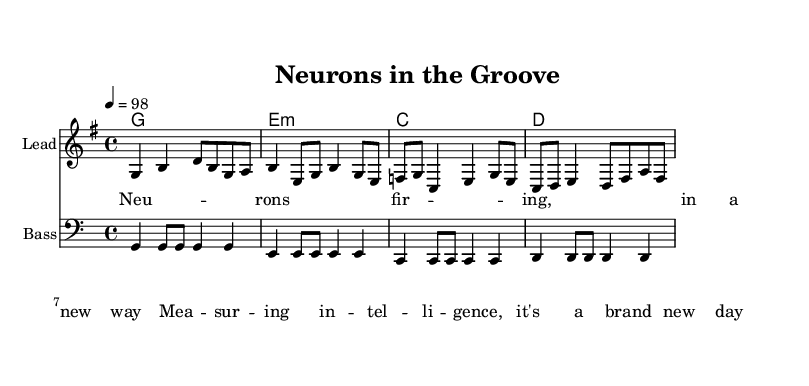What is the key signature of this music? The key signature indicated in the piece is G major, which has one sharp (F#). This can be determined from the global section of the code that sets the key signature to G major.
Answer: G major What is the time signature of this music? The time signature in the music is 4/4, meaning there are four beats in a measure and the quarter note gets one beat. This is also stated in the global section of the code.
Answer: 4/4 What is the tempo marking of this tune? The tempo marking is 98 beats per minute, which is specified in the global section of the code. This indicates the speed at which the piece should be played.
Answer: 98 How many measures are in the melody? The melody contains four measures, as counted from the melody section in the code. Each measure is separated by a bar line, and there are a total of four distinct groups of notes.
Answer: 4 What is the main theme of the lyrics? The main theme of the lyrics discusses new ways of measuring intelligence through the firing of neurons, which connects to scientific discoveries. This can be inferred from the content presented in the verse.
Answer: Intelligence and neurons What type of musical elements are used in reggae as seen in this piece? The reggae style in this piece is indicated by the offbeat guitar chords (common in reggae rhythm), consistent bass lines, and the emphasis on the second and fourth beats, reflecting the genre’s characteristics. This can be inferred from the structure of the harmonies and the bass line.
Answer: Offbeat rhythm What is the harmonic progression used in this piece? The harmonic progression used is G major, E minor, C major, and D major. This is shown in the harmonies section of the code, where each chord represents a measure of the music.
Answer: G, E minor, C, D 